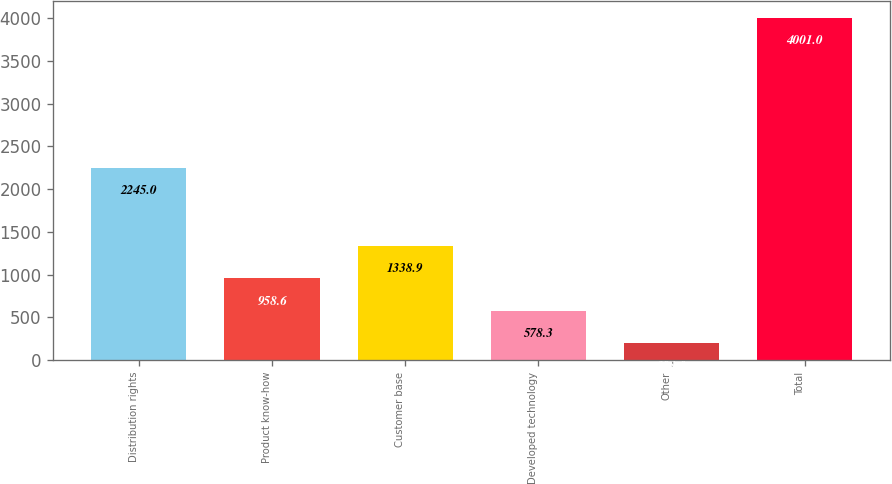<chart> <loc_0><loc_0><loc_500><loc_500><bar_chart><fcel>Distribution rights<fcel>Product know-how<fcel>Customer base<fcel>Developed technology<fcel>Other<fcel>Total<nl><fcel>2245<fcel>958.6<fcel>1338.9<fcel>578.3<fcel>198<fcel>4001<nl></chart> 